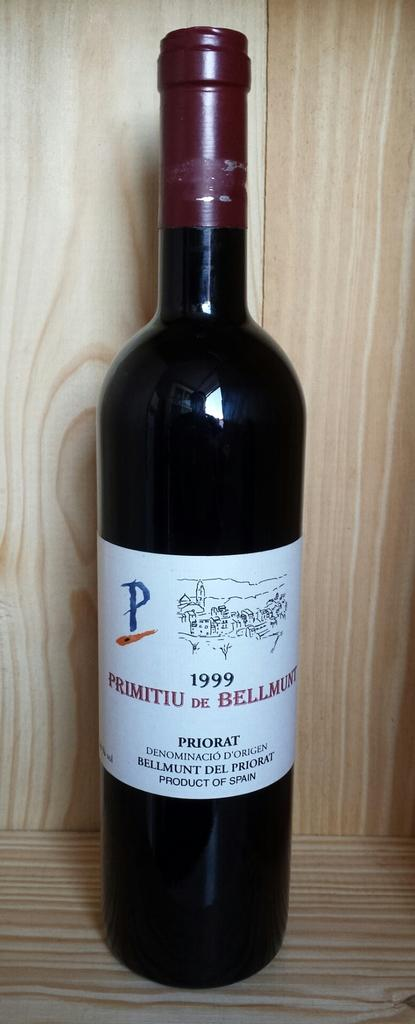What can be seen in the image? There is a bottle in the image. Where is the bottle located? The bottle is on a wooden surface. What is on the bottle? The bottle has a sticker on it. What can be seen in the background of the image? There is a wall visible in the background of the image. Are there any plants growing on the iron bars in the image? There are no plants or iron bars present in the image. 